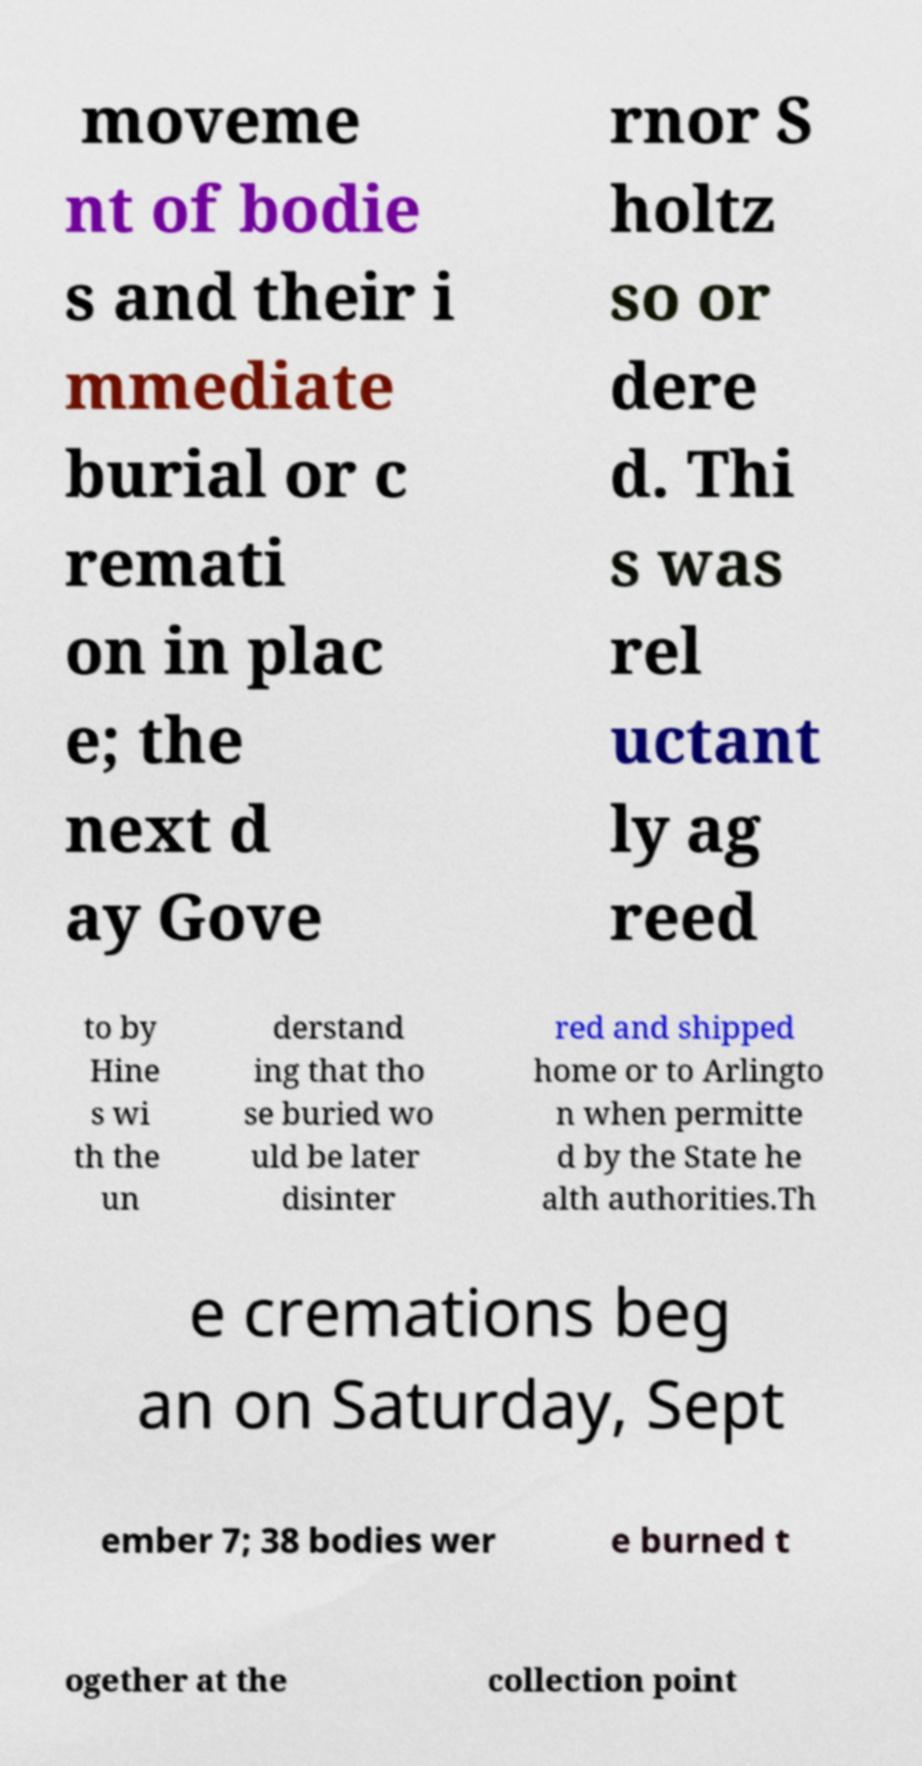There's text embedded in this image that I need extracted. Can you transcribe it verbatim? moveme nt of bodie s and their i mmediate burial or c remati on in plac e; the next d ay Gove rnor S holtz so or dere d. Thi s was rel uctant ly ag reed to by Hine s wi th the un derstand ing that tho se buried wo uld be later disinter red and shipped home or to Arlingto n when permitte d by the State he alth authorities.Th e cremations beg an on Saturday, Sept ember 7; 38 bodies wer e burned t ogether at the collection point 